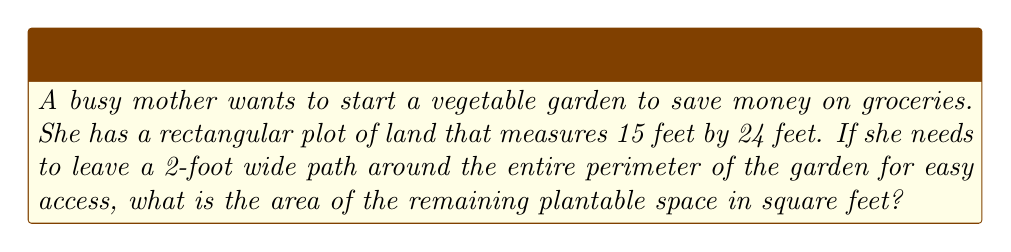What is the answer to this math problem? Let's approach this step-by-step:

1) First, we need to calculate the dimensions of the plantable area:
   - The width will be reduced by 2 feet on each side: $15 - (2 \times 2) = 11$ feet
   - The length will be reduced by 2 feet on each side: $24 - (2 \times 2) = 20$ feet

2) Now we have a new rectangle with dimensions 11 feet by 20 feet.

3) The area of a rectangle is given by the formula:

   $$A = l \times w$$

   Where $A$ is the area, $l$ is the length, and $w$ is the width.

4) Substituting our values:

   $$A = 20 \times 11 = 220$$

5) Therefore, the area of the plantable space is 220 square feet.

[asy]
unitsize(0.2 cm);
fill((0,0)--(24,0)--(24,15)--(0,15)--cycle,lightgray);
fill((2,2)--(22,2)--(22,13)--(2,13)--cycle,green);
draw((0,0)--(24,0)--(24,15)--(0,15)--cycle);
draw((2,2)--(22,2)--(22,13)--(2,13)--cycle);
label("24 ft", (12,-1));
label("15 ft", (25,7.5), E);
label("20 ft", (12,14), N);
label("11 ft", (-1,7.5), W);
label("Plantable Area", (12,7.5));
[/asy]
Answer: 220 sq ft 